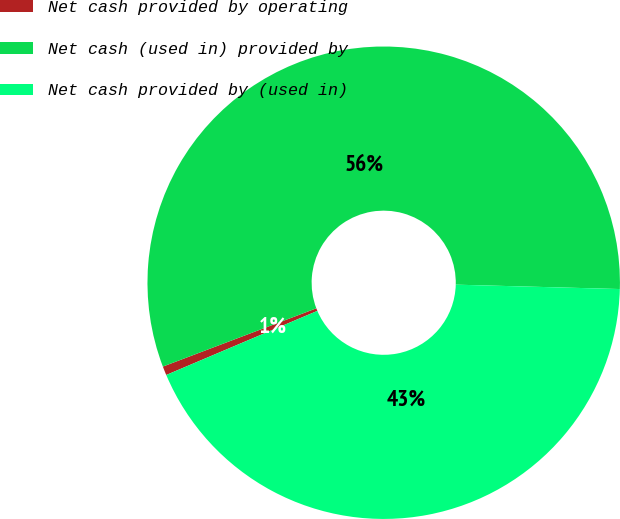Convert chart. <chart><loc_0><loc_0><loc_500><loc_500><pie_chart><fcel>Net cash provided by operating<fcel>Net cash (used in) provided by<fcel>Net cash provided by (used in)<nl><fcel>0.61%<fcel>56.2%<fcel>43.19%<nl></chart> 